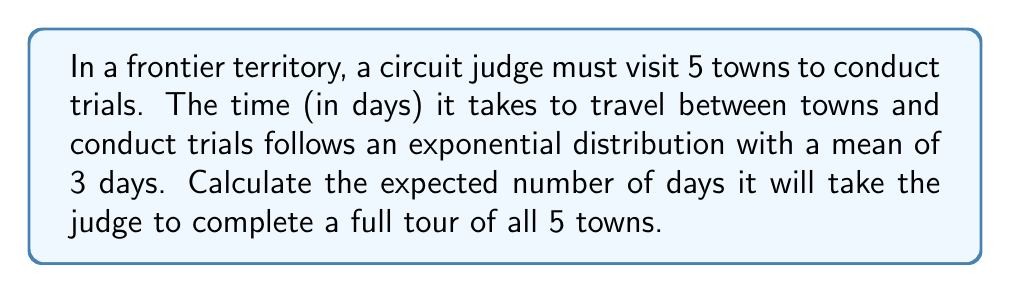What is the answer to this math problem? To solve this problem, we need to understand the properties of exponential distributions and the concept of expected value. Let's break it down step-by-step:

1) The exponential distribution has a probability density function:
   $$f(x) = \lambda e^{-\lambda x}$$
   where $\lambda$ is the rate parameter.

2) The mean of an exponential distribution is given by:
   $$E[X] = \frac{1}{\lambda}$$

3) We're told that the mean is 3 days, so:
   $$3 = \frac{1}{\lambda}$$
   $$\lambda = \frac{1}{3}$$

4) Now, we need to consider that the judge must visit 5 towns. Each visit (including travel and trial) is an independent event following the same exponential distribution.

5) The expected value of the sum of independent random variables is the sum of their individual expected values. So, if we call the total time $T$:
   $$E[T] = E[X_1 + X_2 + X_3 + X_4 + X_5]$$
   $$E[T] = E[X_1] + E[X_2] + E[X_3] + E[X_4] + E[X_5]$$

6) Since each $X_i$ follows the same distribution with mean 3:
   $$E[T] = 3 + 3 + 3 + 3 + 3 = 5 \times 3 = 15$$

Therefore, the expected number of days for the judge to complete a full tour of all 5 towns is 15 days.
Answer: 15 days 